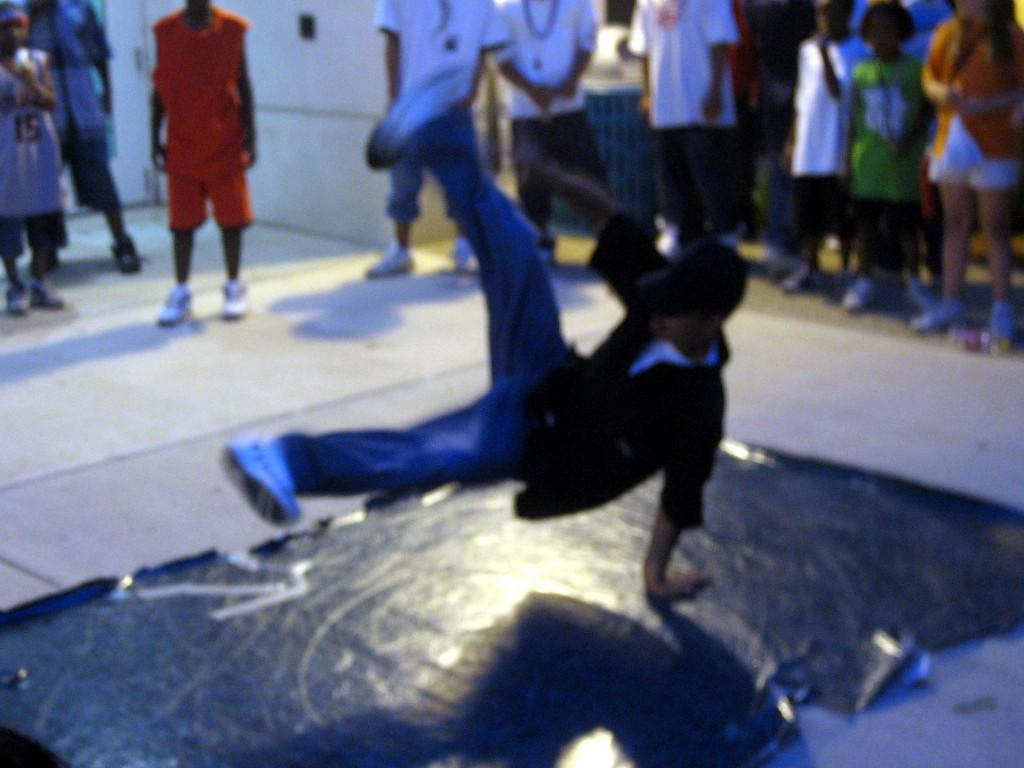What is the person in the image doing? There is a person performing on the floor. Can you describe the people in the background of the image? There are people standing in the background of the image. What type of silk material is being used by the person performing in the image? There is no silk material mentioned or visible in the image. 